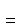<formula> <loc_0><loc_0><loc_500><loc_500>\hat { = }</formula> 